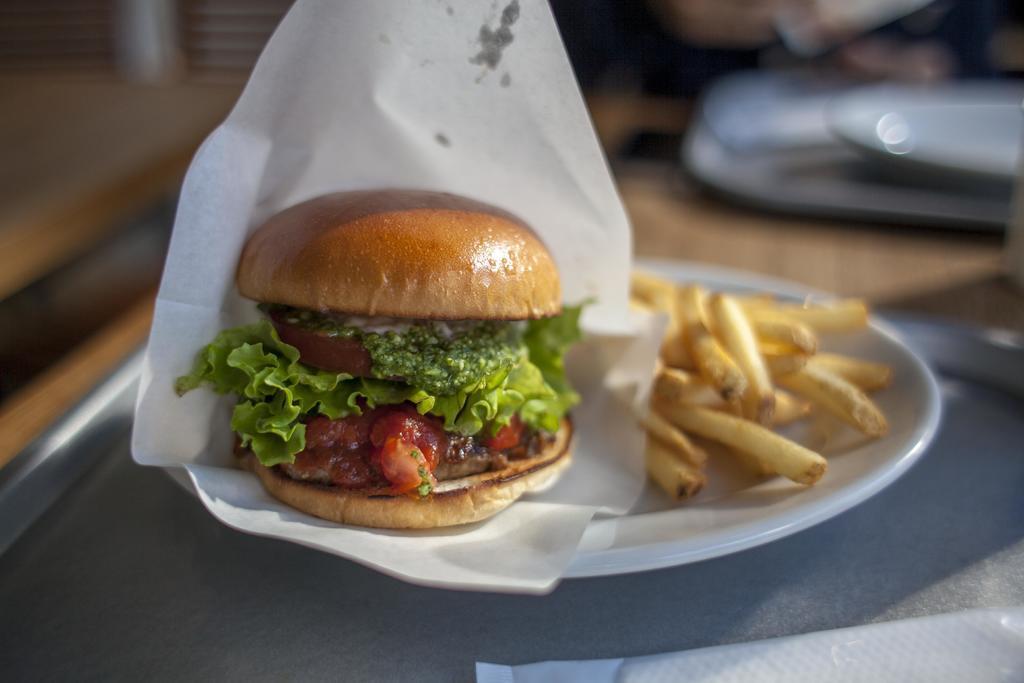In one or two sentences, can you explain what this image depicts? In this image we can see a burger and french fries in a white color plate. At the bottom of the image tray and tissue is present. 